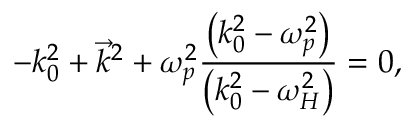<formula> <loc_0><loc_0><loc_500><loc_500>- k _ { 0 } ^ { 2 } + { \vec { k } } ^ { 2 } + \omega _ { p } ^ { 2 } { \frac { \left ( k _ { 0 } ^ { 2 } - \omega _ { p } ^ { 2 } \right ) } { \left ( k _ { 0 } ^ { 2 } - \omega _ { H } ^ { 2 } \right ) } } = 0 ,</formula> 